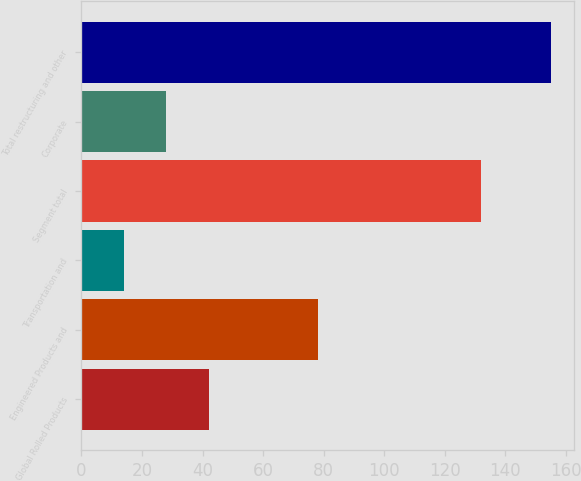Convert chart. <chart><loc_0><loc_0><loc_500><loc_500><bar_chart><fcel>Global Rolled Products<fcel>Engineered Products and<fcel>Transportation and<fcel>Segment total<fcel>Corporate<fcel>Total restructuring and other<nl><fcel>42.2<fcel>78<fcel>14<fcel>132<fcel>28.1<fcel>155<nl></chart> 